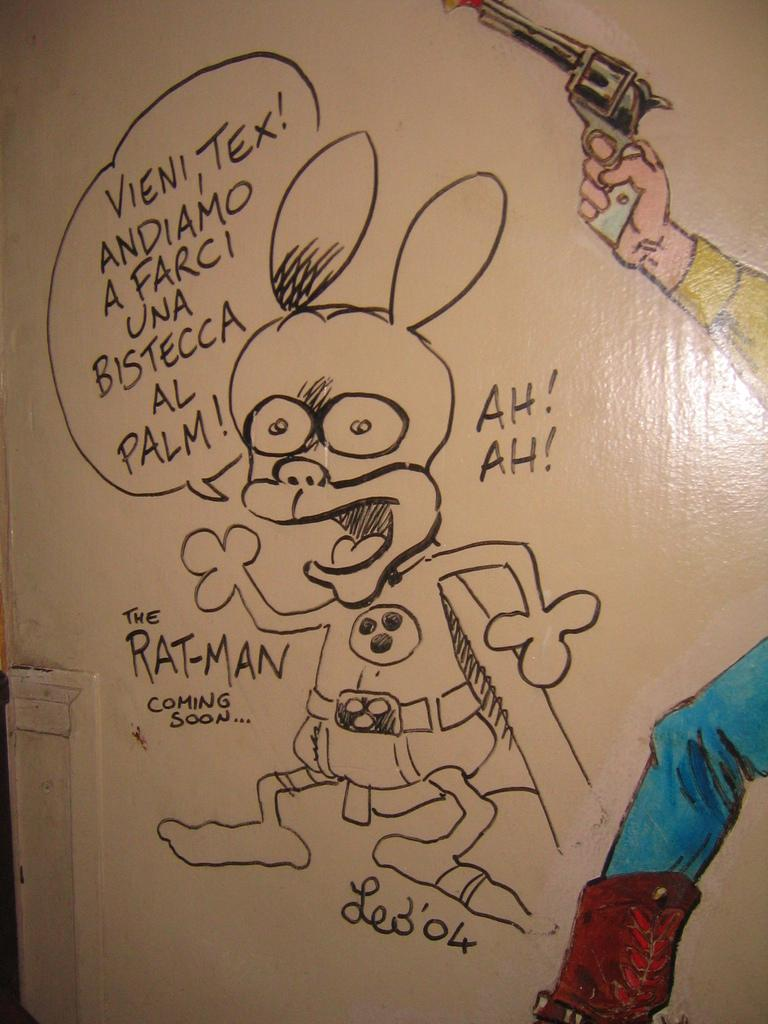What is the person in the image holding? The person in the image is holding a gun. What can be seen on the wall in the image? There is a cartoon painted on the wall and written words in the image. What type of bait is being used to attract the ghost in the image? There is no ghost or bait present in the image; it only features a person holding a gun and a cartoon painted on the wall with written words. 